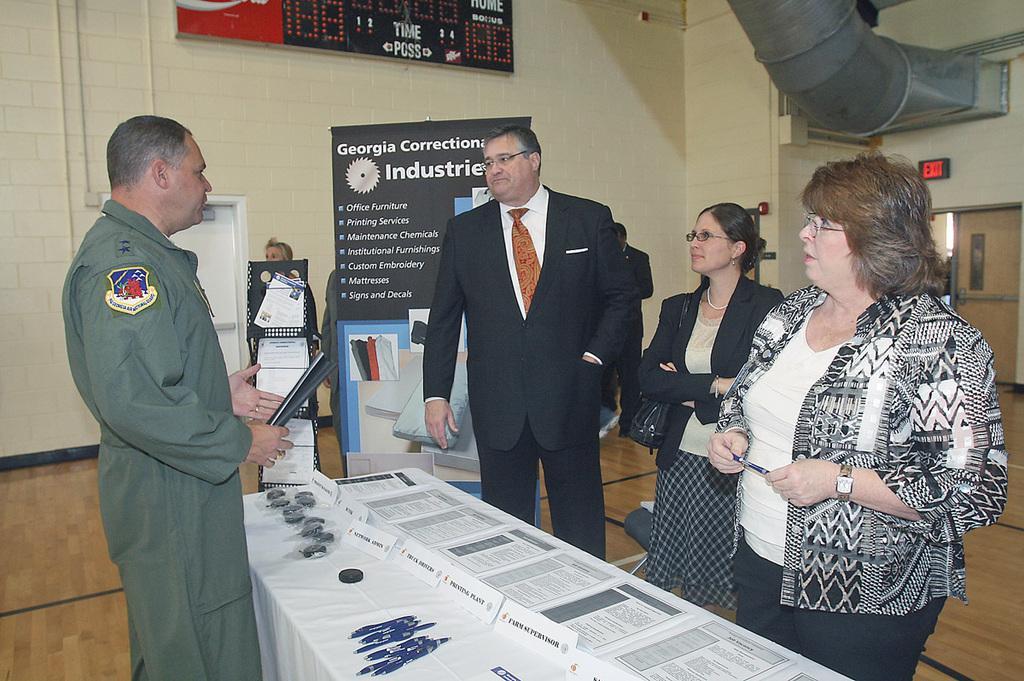In one or two sentences, can you explain what this image depicts? In this image there are two men and two women standing near a table, on that table there are papers and pens background there are posters and a wall. 